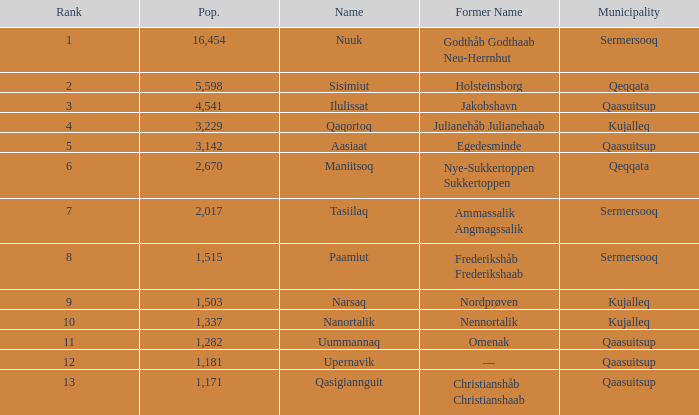What is the population for Rank 11? 1282.0. 